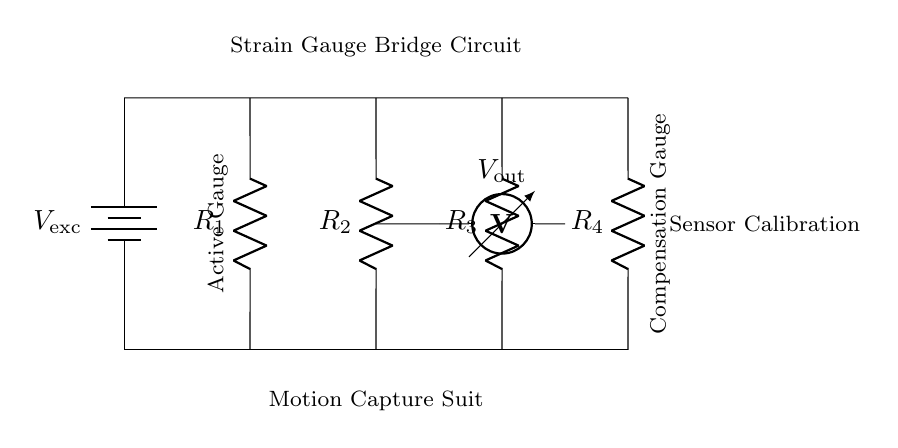What is the power supply in this circuit? The power supply is denoted by the battery symbol, which is labeled as V_ex. This indicates the excitation voltage necessary for the strain gauge bridge to function.
Answer: V_ex How many resistors are present in the bridge circuit? The diagram shows four resistors labeled R_1, R_2, R_3, and R_4. They are essential for balancing the bridge and measuring the strain accurately.
Answer: Four What is the purpose of the voltmeter in the circuit? The voltmeter measures the output voltage, labeled as V_out, which reflects the changes in resistance caused by the applied strain. It is crucial for determining the performance of the strain gauges.
Answer: Measure output voltage Which resistor acts as the active gauge? In this circuit, R_1 is identified as the active gauge. It is connected to the strain gauge that responds to deformation, influencing the output voltage.
Answer: R_1 What is the configuration of the resistors in this circuit? The four resistors are arranged in a Wheatstone bridge configuration, allowing for the detection of small changes in resistance due to strain, which can be converted to a measurable voltage.
Answer: Wheatstone bridge Which components ensure sensor calibration in this setup? The overall configuration of R_1 and the compensation gauges R_2, R_3, and R_4 work together to achieve calibration, allowing for balancing to minimize readings without strain.
Answer: R_1, R_2, R_3, R_4 